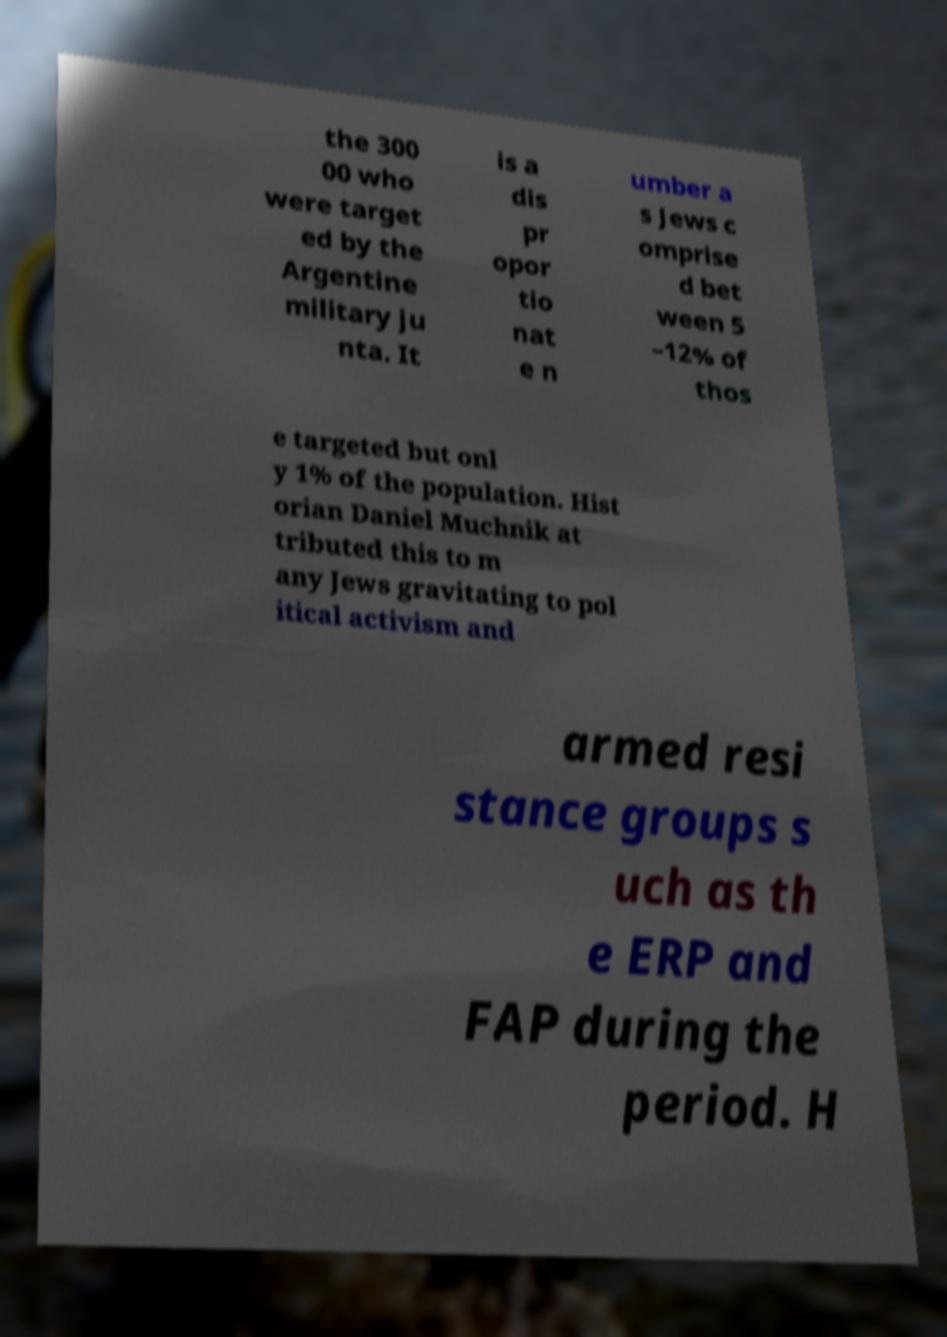Can you accurately transcribe the text from the provided image for me? the 300 00 who were target ed by the Argentine military ju nta. It is a dis pr opor tio nat e n umber a s Jews c omprise d bet ween 5 –12% of thos e targeted but onl y 1% of the population. Hist orian Daniel Muchnik at tributed this to m any Jews gravitating to pol itical activism and armed resi stance groups s uch as th e ERP and FAP during the period. H 